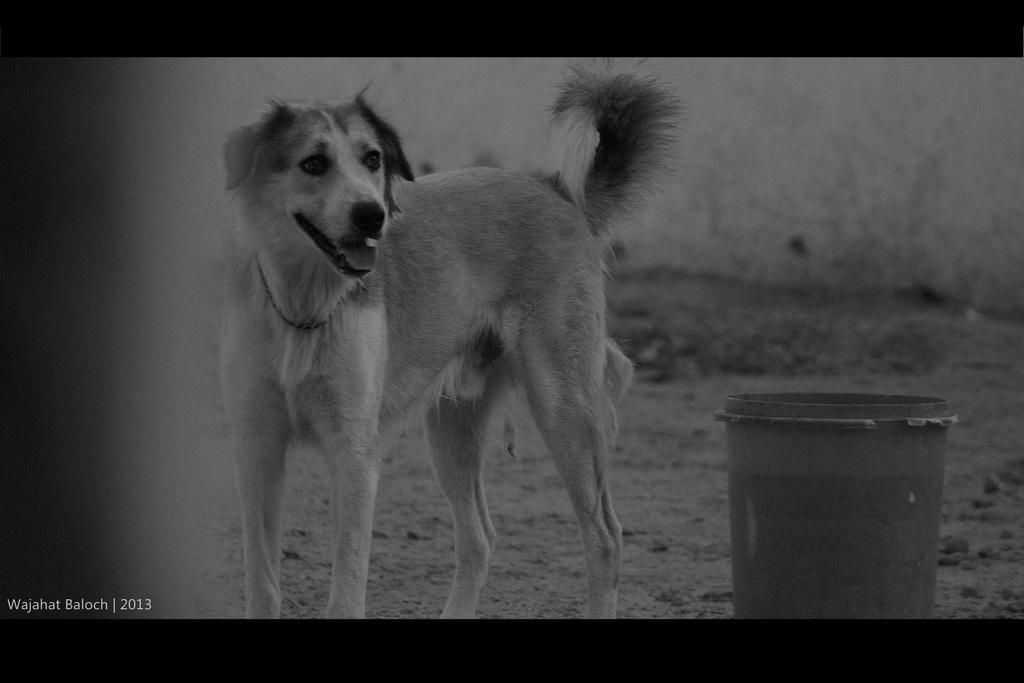What is the color scheme of the image? The image is black and white. What animal can be seen in the image? There is a dog in the image. Where is the bucket located in the image? The bucket is in the bottom right of the image. Can you describe the background of the image? The background of the image is blurred. What type of lead is the dog using to write in the image? There is no lead or writing activity depicted in the image; it features a dog and a bucket. What type of quill is the dog holding in the image? There is no quill or writing activity depicted in the image; it features a dog and a bucket. 